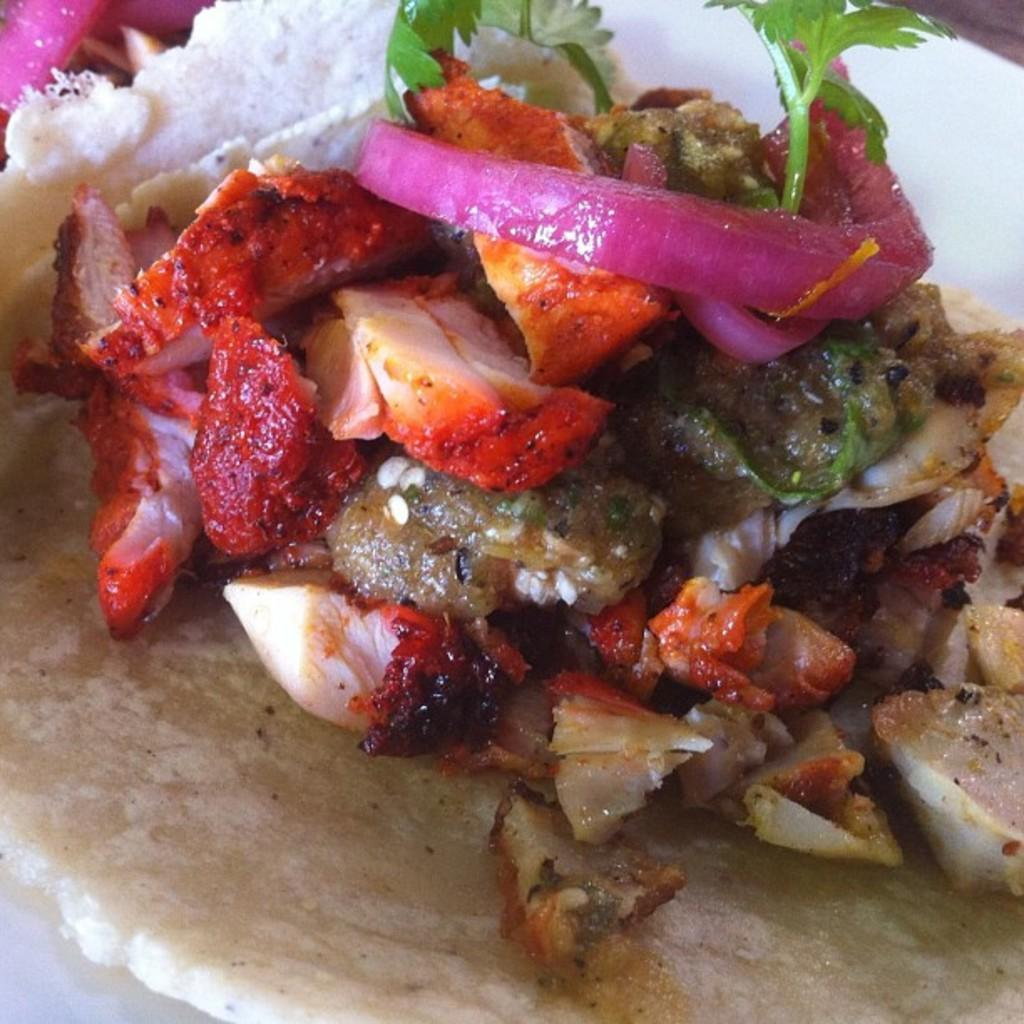What type of items can be seen in the image? There are food items in the image. What specific ingredient is present among the food items? Coriander leaves are present in the image. How are the food items and coriander leaves arranged in the image? Both the food items and coriander leaves are in a plate. What type of flowers can be seen in the image? There are no flowers present in the image; it features food items and coriander leaves in a plate. What type of music is playing in the background of the image? There is no music present in the image; it only shows food items and coriander leaves in a plate. 